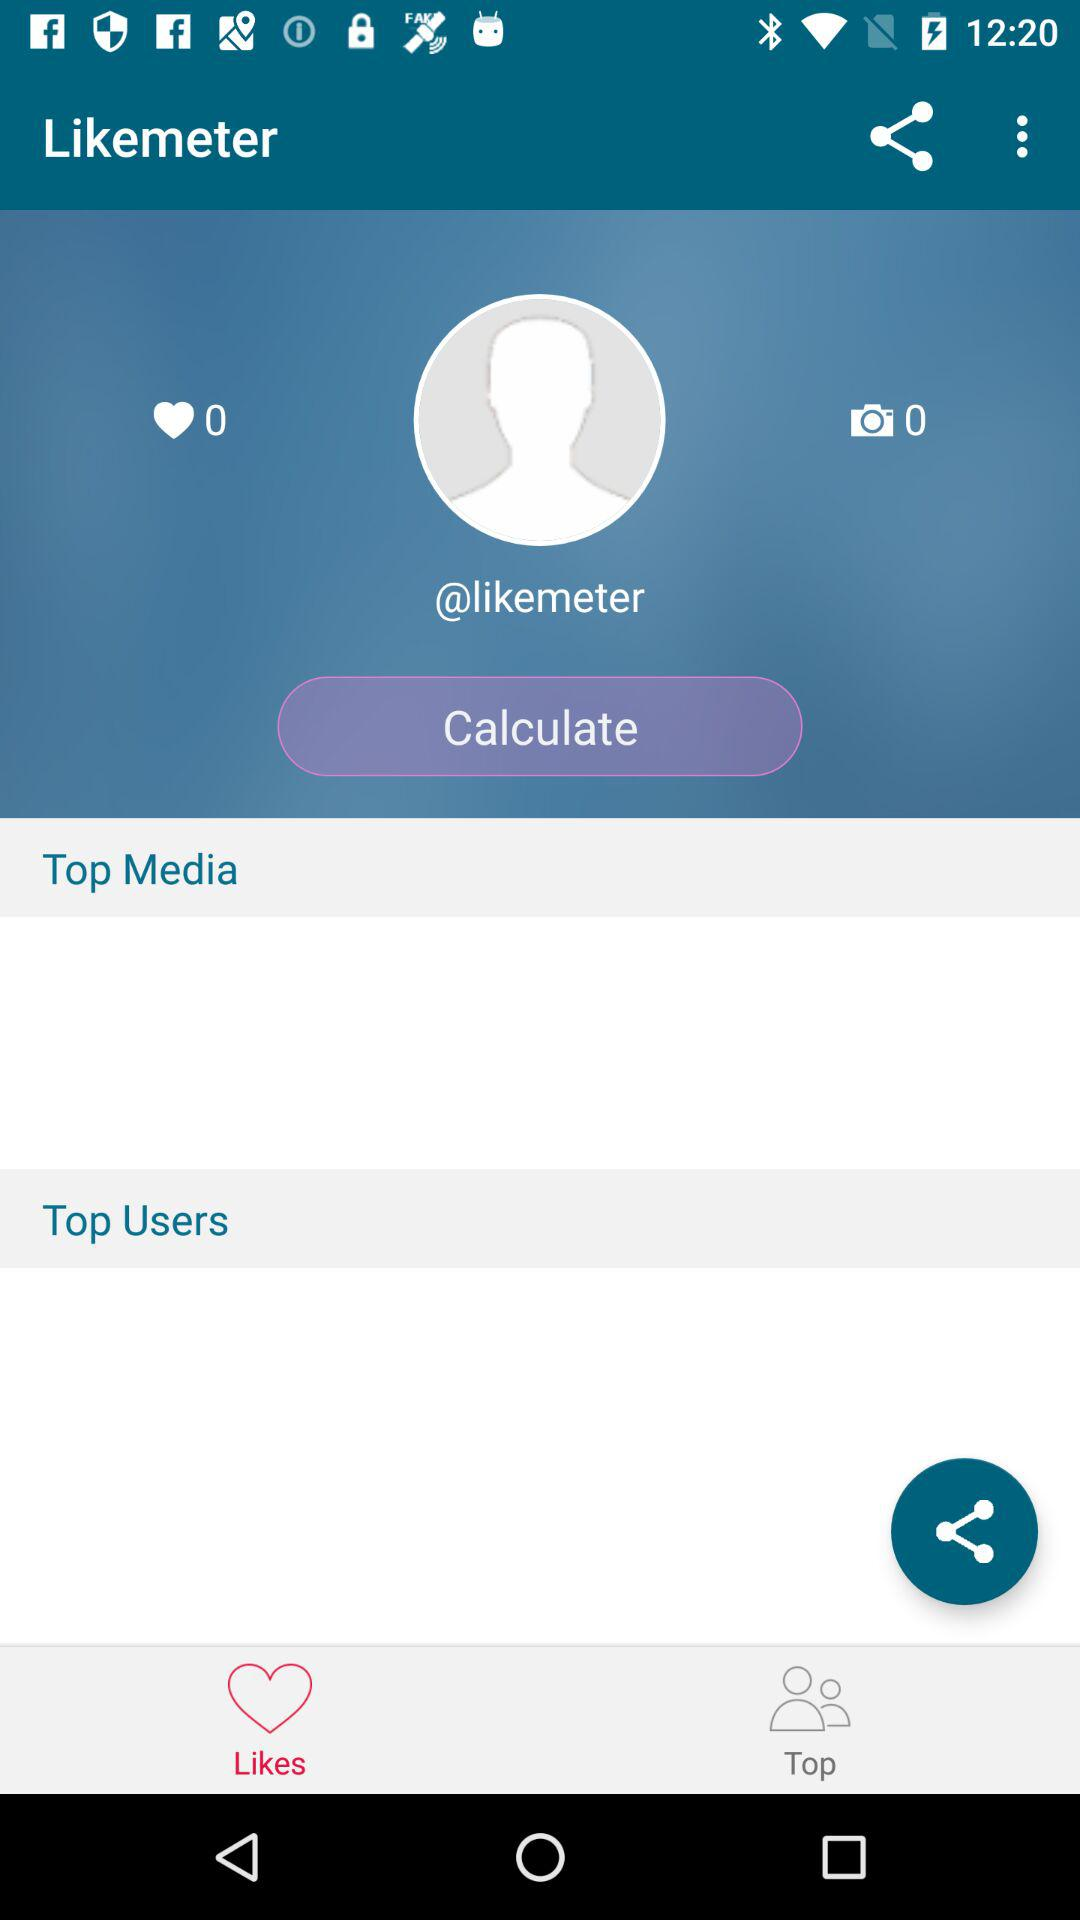How many likes did the person get? The person got 0 likes. 